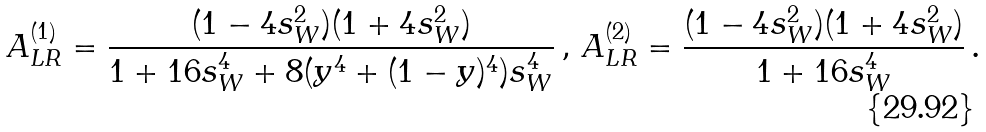Convert formula to latex. <formula><loc_0><loc_0><loc_500><loc_500>A _ { L R } ^ { ( 1 ) } = \frac { ( 1 - 4 s _ { W } ^ { 2 } ) ( 1 + 4 s _ { W } ^ { 2 } ) } { 1 + 1 6 s _ { W } ^ { 4 } + 8 ( y ^ { 4 } + ( 1 - y ) ^ { 4 } ) s _ { W } ^ { 4 } } \, , \, A _ { L R } ^ { ( 2 ) } = \frac { ( 1 - 4 s _ { W } ^ { 2 } ) ( 1 + 4 s _ { W } ^ { 2 } ) } { 1 + 1 6 s _ { W } ^ { 4 } } \, .</formula> 